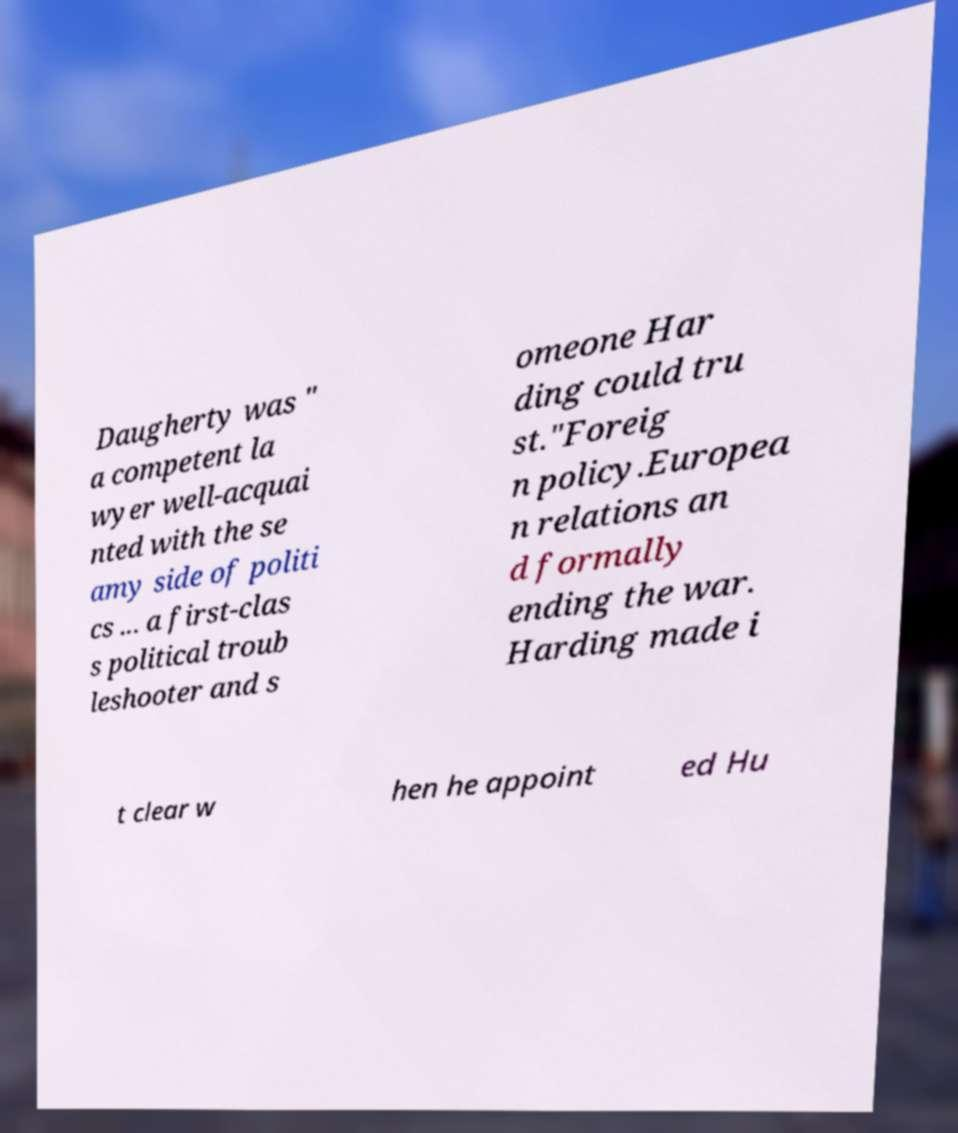Can you accurately transcribe the text from the provided image for me? Daugherty was " a competent la wyer well-acquai nted with the se amy side of politi cs ... a first-clas s political troub leshooter and s omeone Har ding could tru st."Foreig n policy.Europea n relations an d formally ending the war. Harding made i t clear w hen he appoint ed Hu 